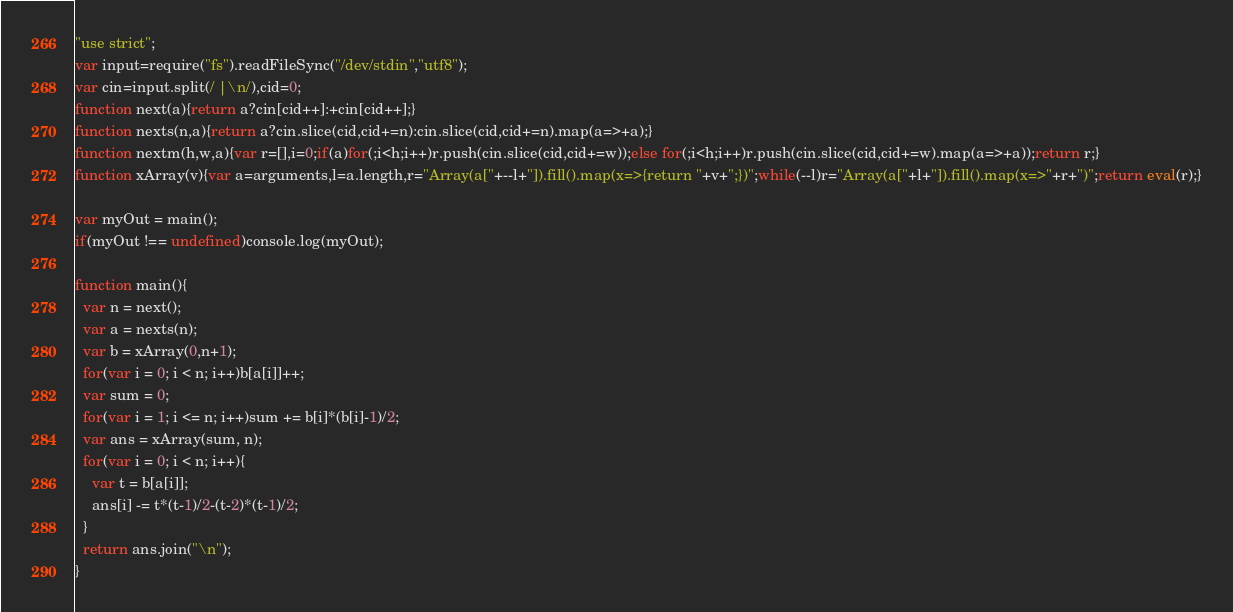<code> <loc_0><loc_0><loc_500><loc_500><_JavaScript_>"use strict";
var input=require("fs").readFileSync("/dev/stdin","utf8");
var cin=input.split(/ |\n/),cid=0;
function next(a){return a?cin[cid++]:+cin[cid++];}
function nexts(n,a){return a?cin.slice(cid,cid+=n):cin.slice(cid,cid+=n).map(a=>+a);}
function nextm(h,w,a){var r=[],i=0;if(a)for(;i<h;i++)r.push(cin.slice(cid,cid+=w));else for(;i<h;i++)r.push(cin.slice(cid,cid+=w).map(a=>+a));return r;}
function xArray(v){var a=arguments,l=a.length,r="Array(a["+--l+"]).fill().map(x=>{return "+v+";})";while(--l)r="Array(a["+l+"]).fill().map(x=>"+r+")";return eval(r);}

var myOut = main();
if(myOut !== undefined)console.log(myOut);

function main(){
  var n = next();
  var a = nexts(n);
  var b = xArray(0,n+1);
  for(var i = 0; i < n; i++)b[a[i]]++;
  var sum = 0;
  for(var i = 1; i <= n; i++)sum += b[i]*(b[i]-1)/2;
  var ans = xArray(sum, n);
  for(var i = 0; i < n; i++){
    var t = b[a[i]];
    ans[i] -= t*(t-1)/2-(t-2)*(t-1)/2;
  }
  return ans.join("\n");
}</code> 